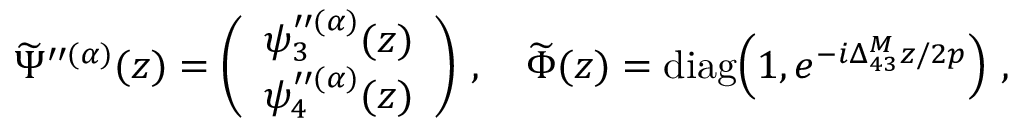<formula> <loc_0><loc_0><loc_500><loc_500>\widetilde { \Psi } ^ { \prime \prime ( \alpha ) } ( z ) = \left ( \begin{array} { c } { { \psi _ { 3 } ^ { \prime \prime ( \alpha ) } ( z ) } } \\ { { \psi _ { 4 } ^ { \prime \prime ( \alpha ) } ( z ) } } \end{array} \right ) \, , \quad \widetilde { \Phi } ( z ) = d i a g \, \left ( 1 , e ^ { - i \Delta _ { 4 3 } ^ { M } z / 2 p } \right ) \, ,</formula> 